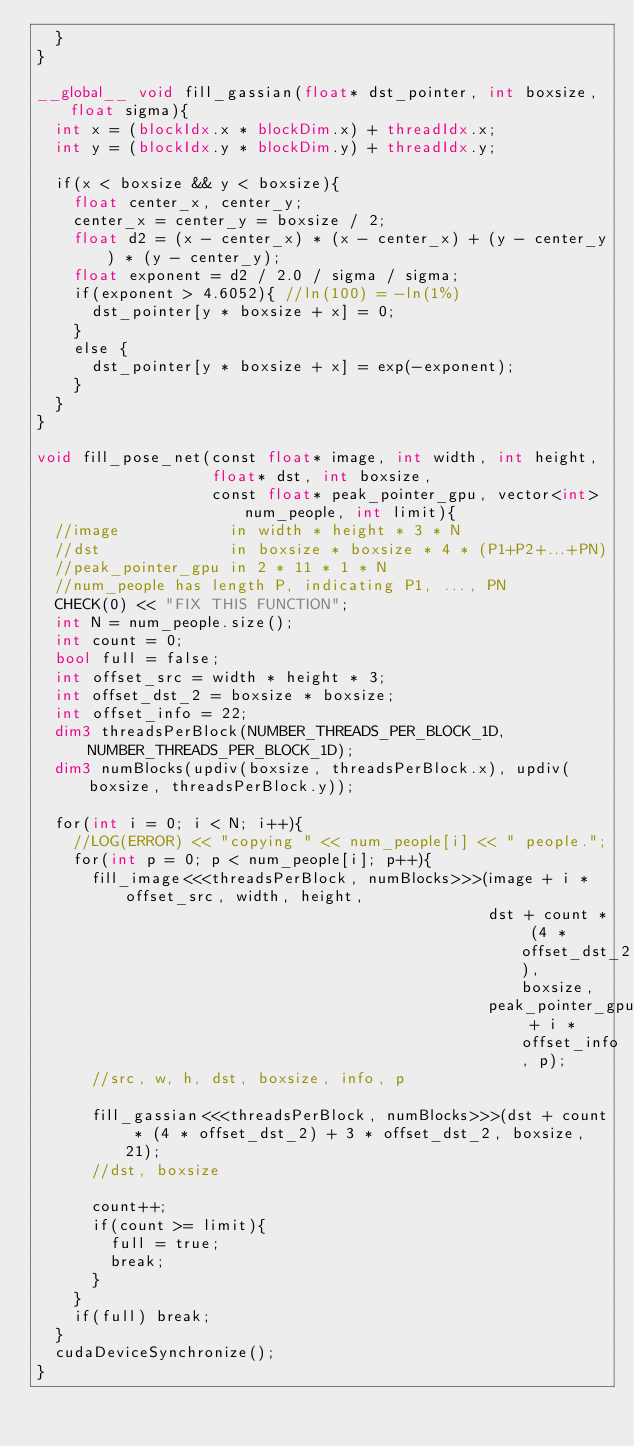<code> <loc_0><loc_0><loc_500><loc_500><_Cuda_>  }
}

__global__ void fill_gassian(float* dst_pointer, int boxsize, float sigma){
  int x = (blockIdx.x * blockDim.x) + threadIdx.x;
  int y = (blockIdx.y * blockDim.y) + threadIdx.y;

  if(x < boxsize && y < boxsize){
    float center_x, center_y;
    center_x = center_y = boxsize / 2;
    float d2 = (x - center_x) * (x - center_x) + (y - center_y) * (y - center_y);
    float exponent = d2 / 2.0 / sigma / sigma;
    if(exponent > 4.6052){ //ln(100) = -ln(1%)
      dst_pointer[y * boxsize + x] = 0;
    }
    else {
      dst_pointer[y * boxsize + x] = exp(-exponent);
    }
  }
}

void fill_pose_net(const float* image, int width, int height,
                   float* dst, int boxsize,
                   const float* peak_pointer_gpu, vector<int> num_people, int limit){
  //image            in width * height * 3 * N
  //dst              in boxsize * boxsize * 4 * (P1+P2+...+PN)
  //peak_pointer_gpu in 2 * 11 * 1 * N
  //num_people has length P, indicating P1, ..., PN
  CHECK(0) << "FIX THIS FUNCTION";
  int N = num_people.size();
  int count = 0;
  bool full = false;
  int offset_src = width * height * 3;
  int offset_dst_2 = boxsize * boxsize;
  int offset_info = 22;
  dim3 threadsPerBlock(NUMBER_THREADS_PER_BLOCK_1D, NUMBER_THREADS_PER_BLOCK_1D);
  dim3 numBlocks(updiv(boxsize, threadsPerBlock.x), updiv(boxsize, threadsPerBlock.y));

  for(int i = 0; i < N; i++){
    //LOG(ERROR) << "copying " << num_people[i] << " people.";
    for(int p = 0; p < num_people[i]; p++){
      fill_image<<<threadsPerBlock, numBlocks>>>(image + i * offset_src, width, height,
                                                 dst + count * (4 * offset_dst_2), boxsize,
                                                 peak_pointer_gpu + i * offset_info, p);
      //src, w, h, dst, boxsize, info, p

      fill_gassian<<<threadsPerBlock, numBlocks>>>(dst + count * (4 * offset_dst_2) + 3 * offset_dst_2, boxsize, 21);
      //dst, boxsize

      count++;
      if(count >= limit){
        full = true;
        break;
      }
    }
    if(full) break;
  }
  cudaDeviceSynchronize();
}
</code> 